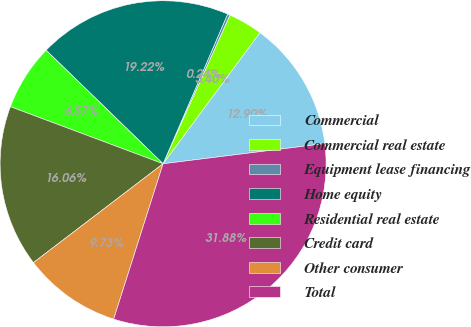Convert chart to OTSL. <chart><loc_0><loc_0><loc_500><loc_500><pie_chart><fcel>Commercial<fcel>Commercial real estate<fcel>Equipment lease financing<fcel>Home equity<fcel>Residential real estate<fcel>Credit card<fcel>Other consumer<fcel>Total<nl><fcel>12.9%<fcel>3.4%<fcel>0.24%<fcel>19.22%<fcel>6.57%<fcel>16.06%<fcel>9.73%<fcel>31.88%<nl></chart> 